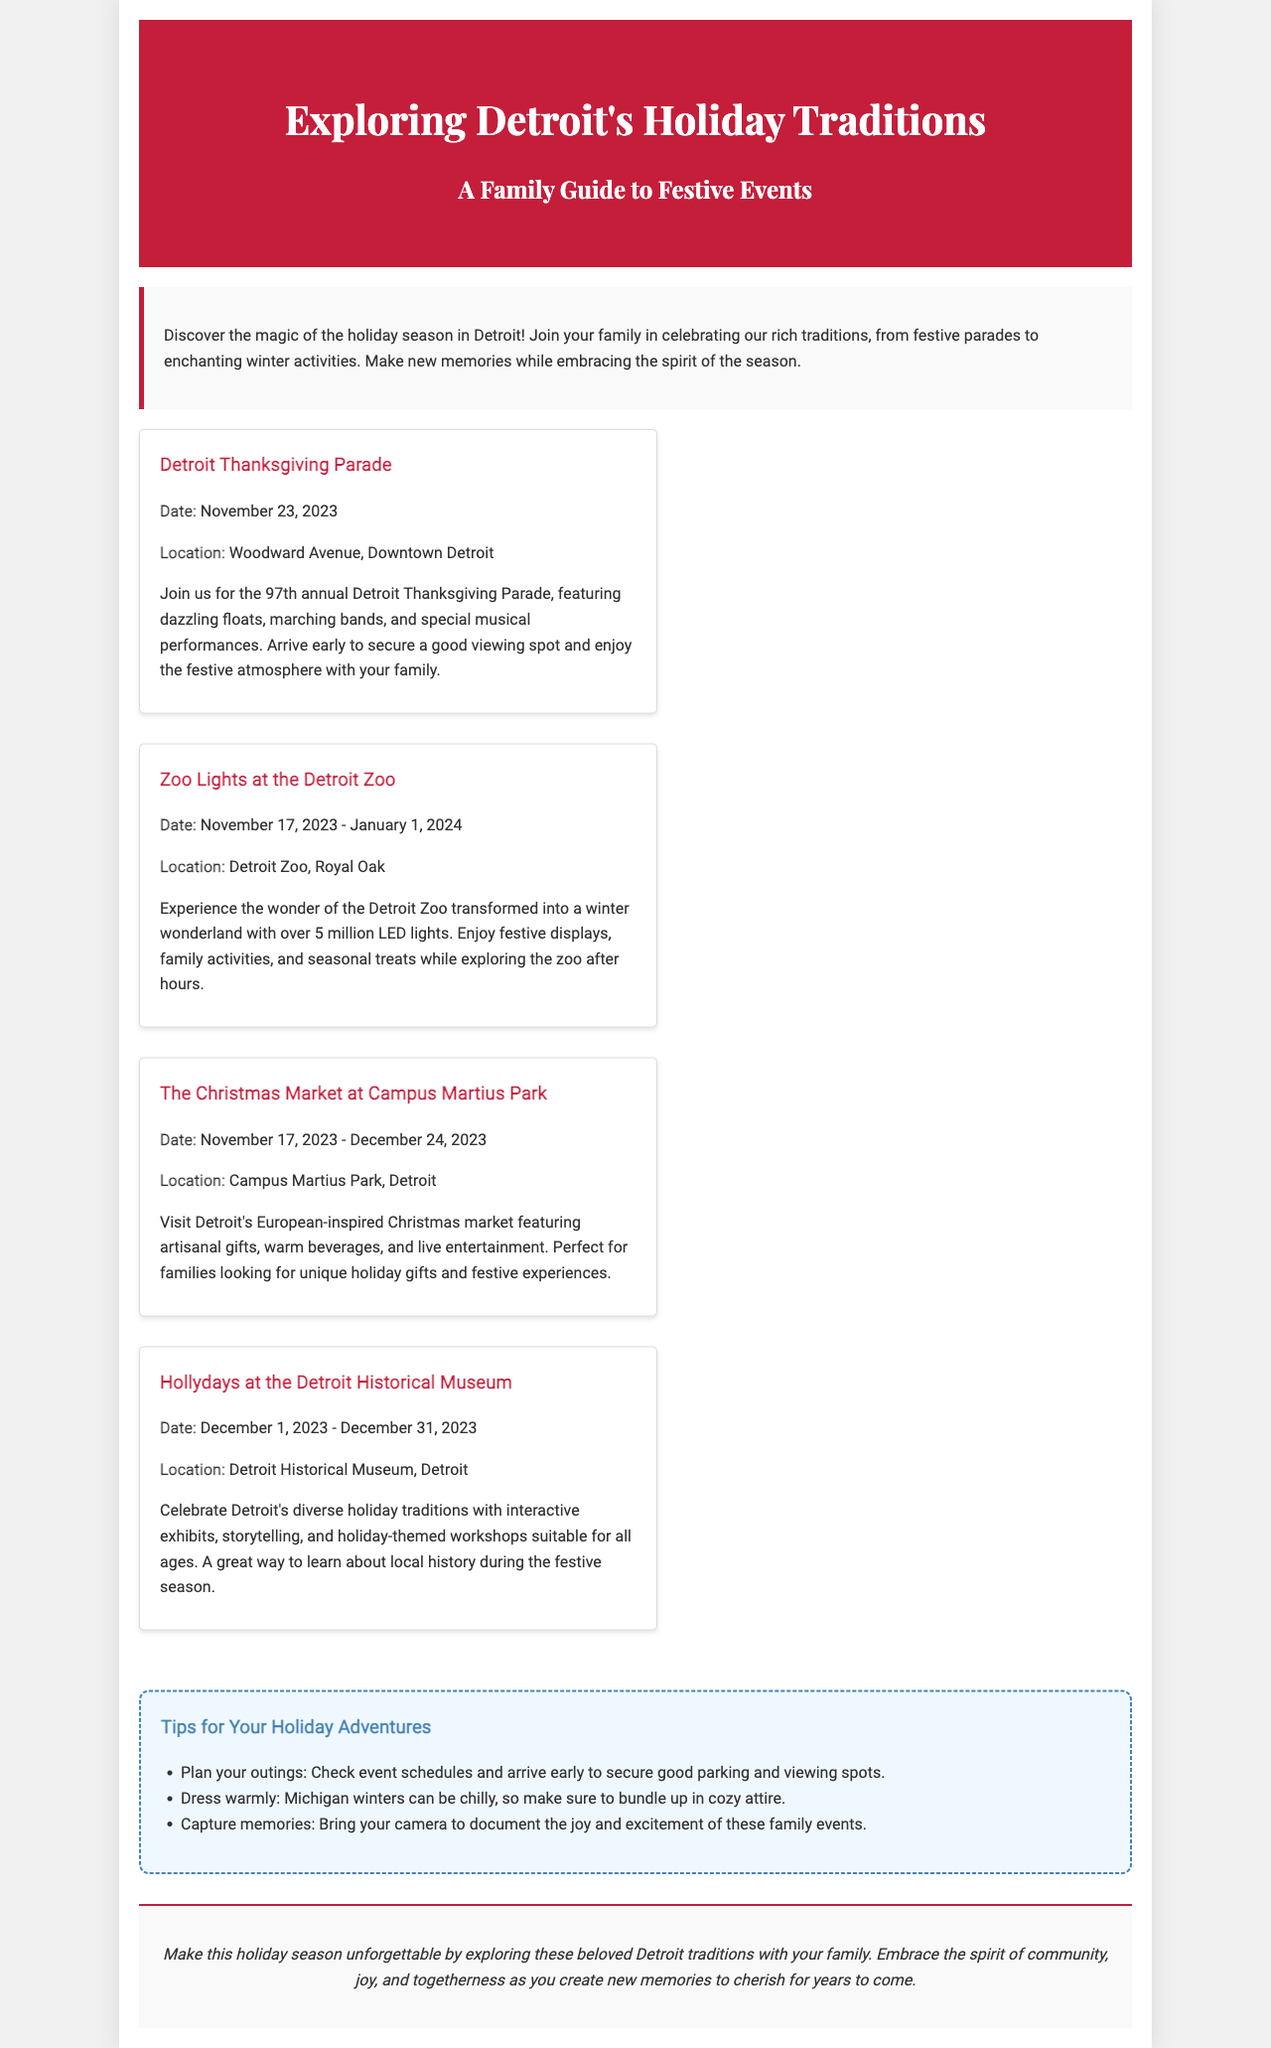What is the date of the Detroit Thanksgiving Parade? The date of the Detroit Thanksgiving Parade is mentioned in the events section of the brochure.
Answer: November 23, 2023 Where is the Christmas Market held? The location of the Christmas Market is specified in the events section.
Answer: Campus Martius Park, Detroit How many LED lights are featured at the Zoo Lights event? The number of LED lights is mentioned in the description of the Zoo Lights event.
Answer: Over 5 million What type of events are included in Hollydays at the Detroit Historical Museum? The types of events are described in the Hollydays section, providing insight into the variety of activities.
Answer: Interactive exhibits, storytelling, workshops What should families bring to capture memories? The tips section provides recommendations for preparing for holiday outings.
Answer: Camera What do families experience at the Christmas Market? This question requires reasoning about the offerings mentioned in the Christmas Market's description.
Answer: Artisanal gifts, warm beverages, live entertainment When does Zoo Lights start? The start date of Zoo Lights is provided in the specific events section.
Answer: November 17, 2023 What color is the header background? This question references the visual aesthetics described for the brochure header.
Answer: Red 